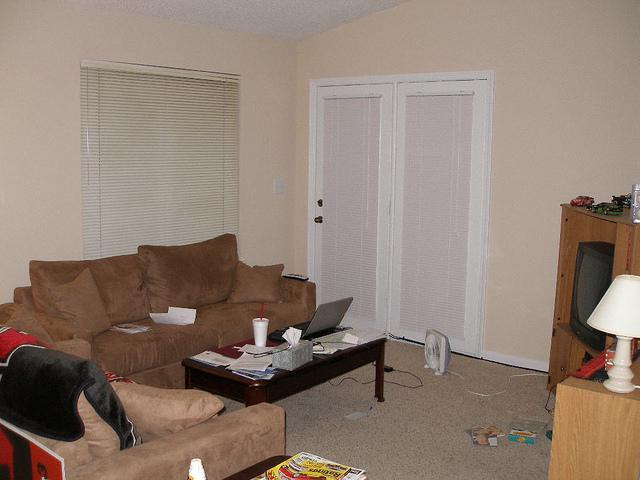What poses the biggest threat for a person to trip on?

Choices:
A) couch
B) cords
C) table
D) lamp cords 